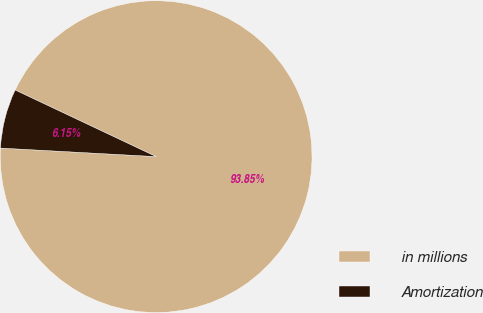Convert chart to OTSL. <chart><loc_0><loc_0><loc_500><loc_500><pie_chart><fcel>in millions<fcel>Amortization<nl><fcel>93.85%<fcel>6.15%<nl></chart> 